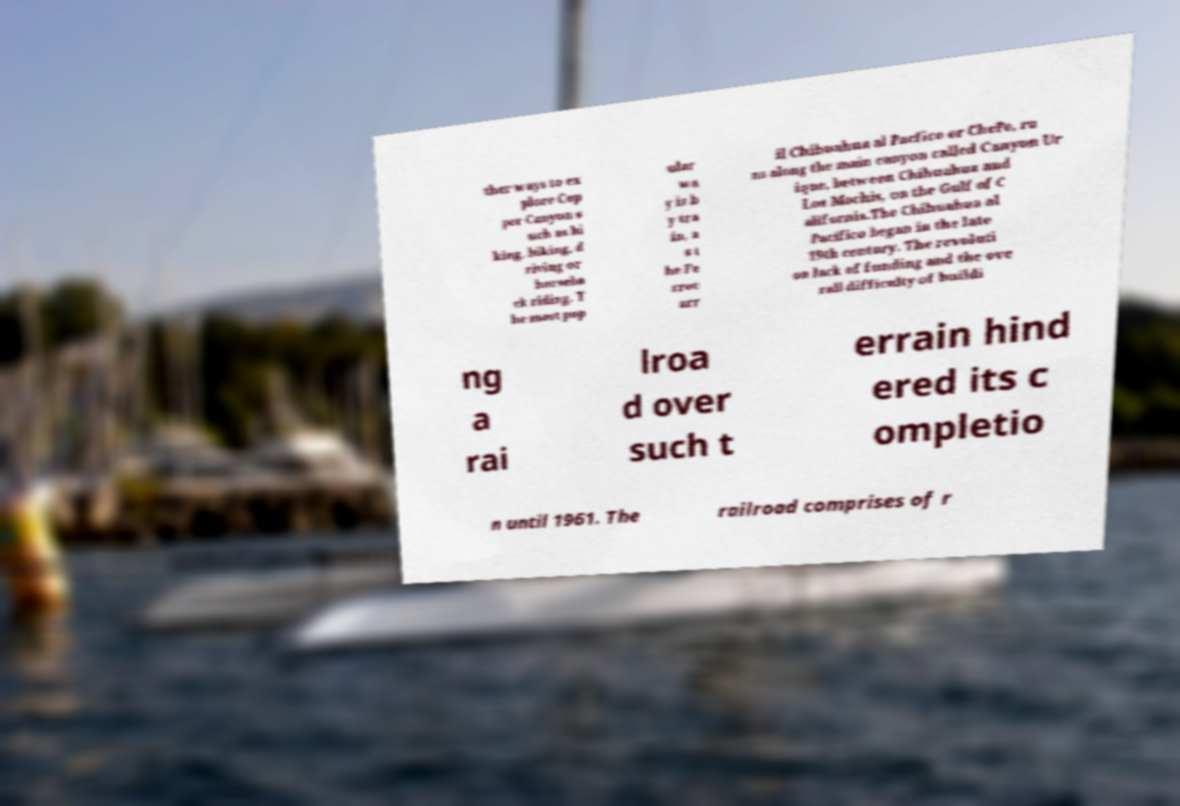Could you assist in decoding the text presented in this image and type it out clearly? ther ways to ex plore Cop per Canyon s uch as hi king, biking, d riving or horseba ck riding. T he most pop ular wa y is b y tra in, a s t he Fe rroc arr il Chihuahua al Pacfico or ChePe, ru ns along the main canyon called Canyon Ur ique, between Chihuahua and Los Mochis, on the Gulf of C alifornia.The Chihuahua al Pacifico began in the late 19th century. The revoluti on lack of funding and the ove rall difficulty of buildi ng a rai lroa d over such t errain hind ered its c ompletio n until 1961. The railroad comprises of r 